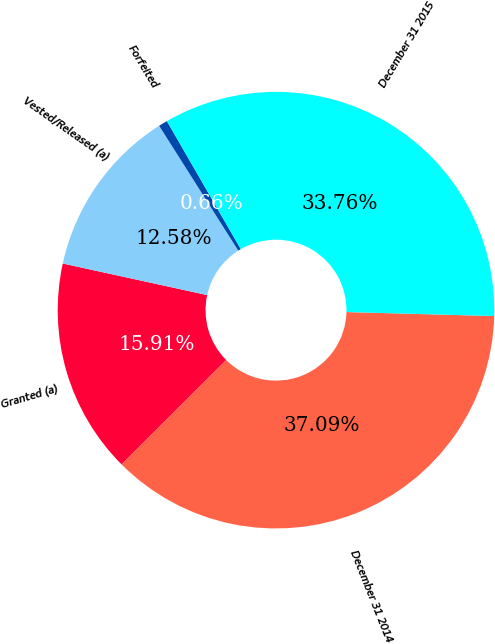Convert chart to OTSL. <chart><loc_0><loc_0><loc_500><loc_500><pie_chart><fcel>December 31 2014<fcel>Granted (a)<fcel>Vested/Released (a)<fcel>Forfeited<fcel>December 31 2015<nl><fcel>37.09%<fcel>15.91%<fcel>12.58%<fcel>0.66%<fcel>33.76%<nl></chart> 